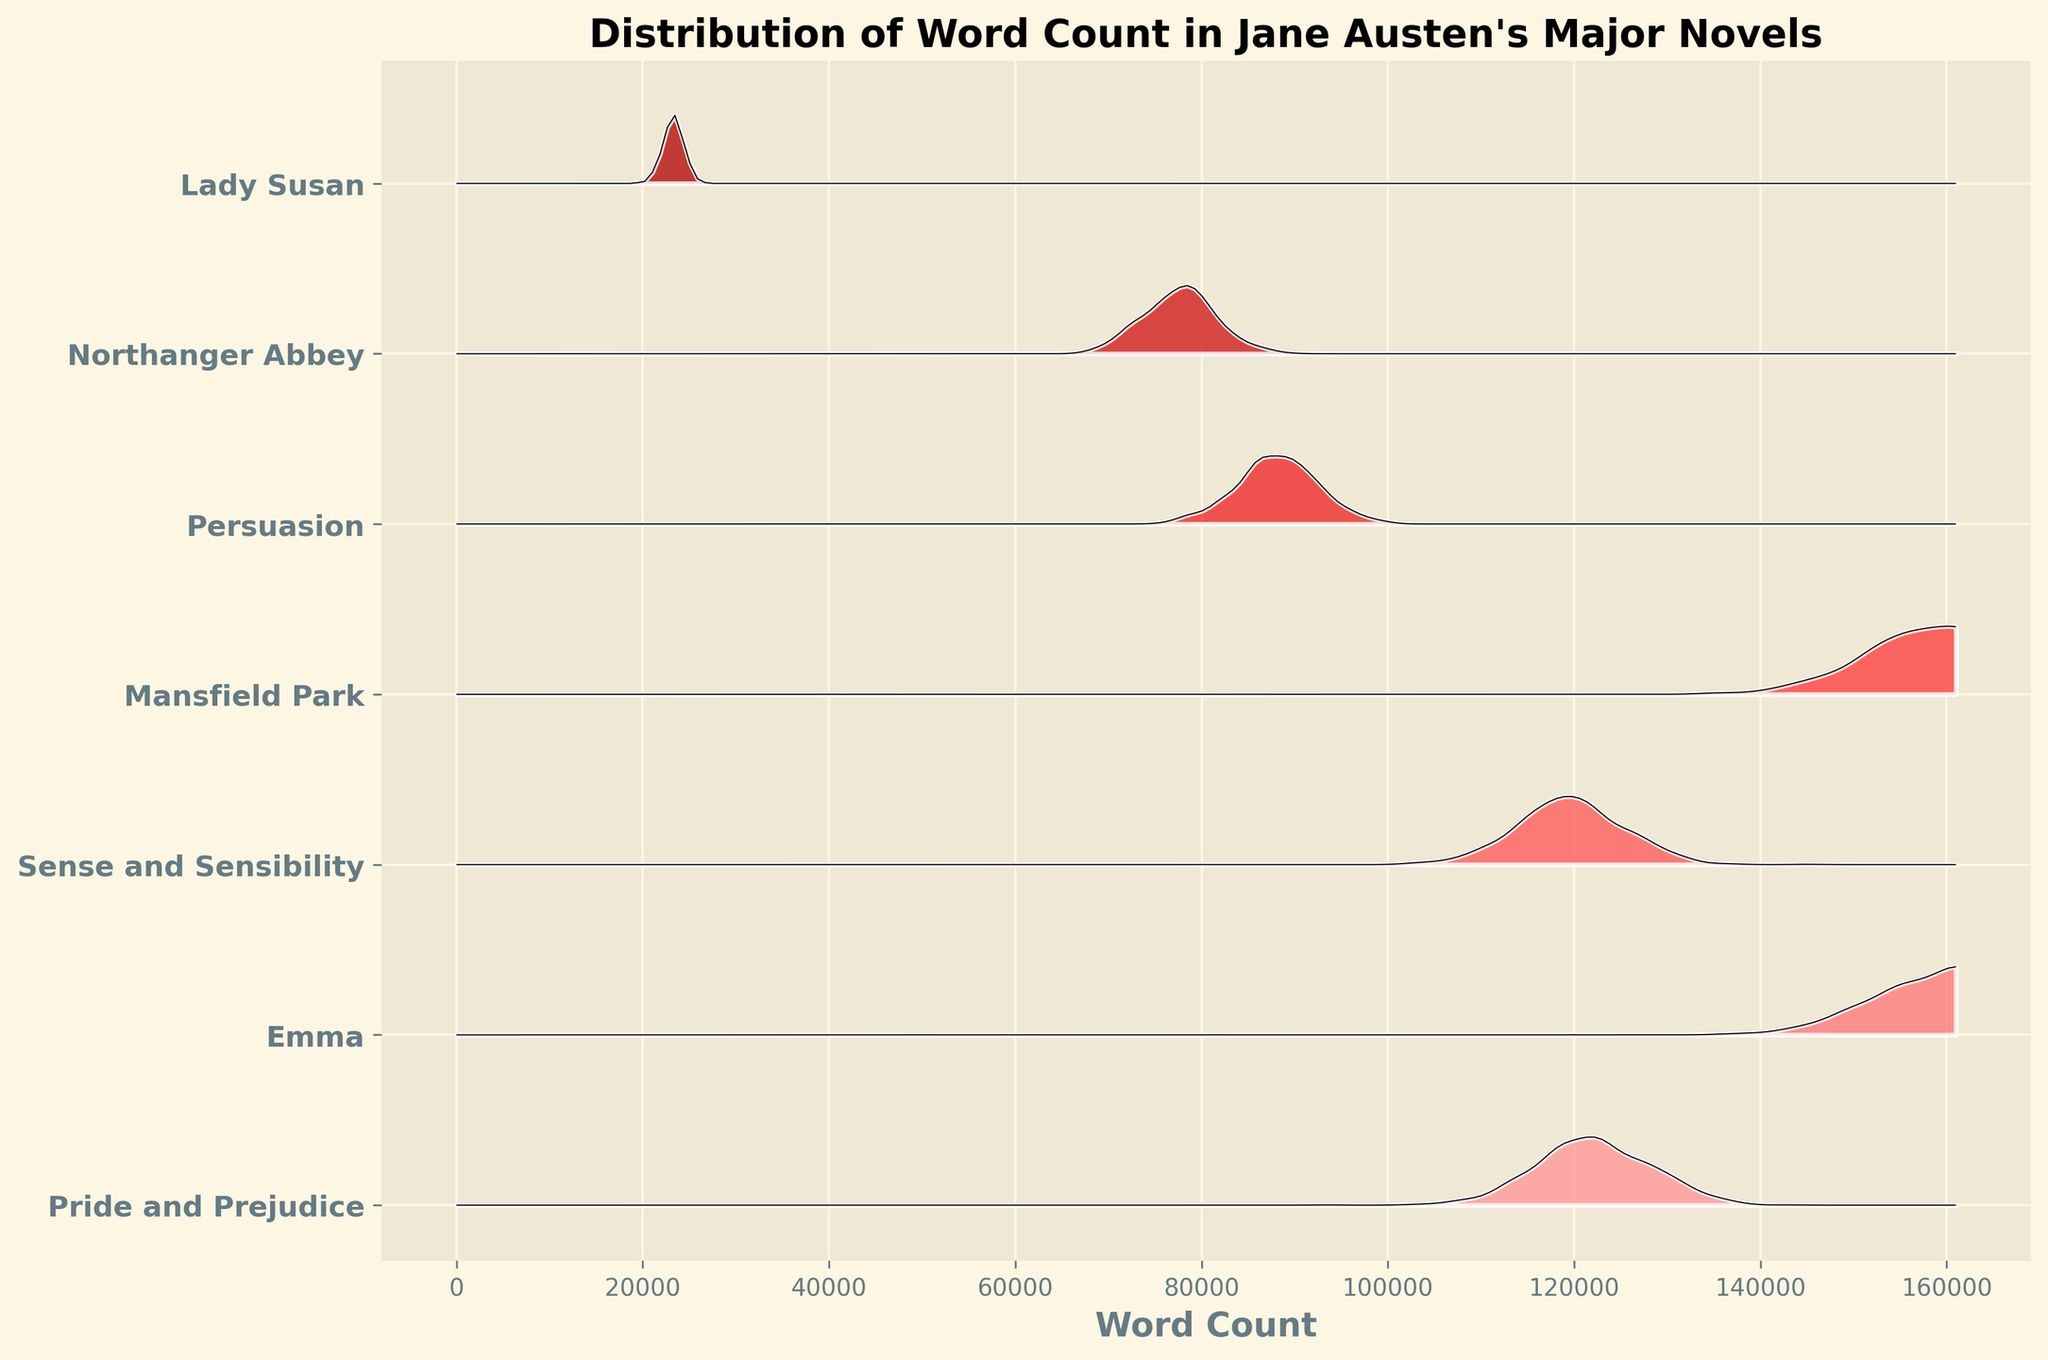What's the title of the plot? The title of the plot is displayed at the top of the figure.
Answer: Distribution of Word Count in Jane Austen's Major Novels What is the novel with the highest word count? By looking at the y-axis labels and the distribution that extends furthest along the x-axis, you can identify the novel with the highest point.
Answer: Emma Which novel has the smallest word count? As with the previous question, examine the y-axis labels and the distribution that is shortest along the x-axis.
Answer: Lady Susan Which two novels have the most similar word counts? Find two distributions that align closely on the x-axis, indicating similar values.
Answer: Mansfield Park and Emma What is the range of word counts depicted in the plot? Look at the extreme values along the x-axis to find the range. The smallest value is around Lady Susan's word count, and the largest is around Emma's.
Answer: ~23,258 to ~160,996 Which novel has the highest density of word count? The density is indicated by the height and intensity of the ridges. The novel with the tallest and darkest ridge has the highest density.
Answer: Lady Susan How does the word count distribution of Pride and Prejudice compare to that of Sense and Sensibility? Compare the positions and shapes of their ridgelines along the x-axis to see if one extends further or if their densities differ.
Answer: Very similar; both peak around the same word count Rank the novels from highest to lowest word count. Identify the order of novels based on the extent of their ridgeline along the x-axis from largest to smallest values. Use your own judgement based on the figure.
Answer: Emma, Mansfield Park, Pride and Prejudice, Sense and Sensibility, Persuasion, Northanger Abbey, Lady Susan How do the word counts of Persuasion and Northanger Abbey differ? Compare the lengths of their distributions along the x-axis, noting which one extends further.
Answer: Northanger Abbey has fewer words than Persuasion 